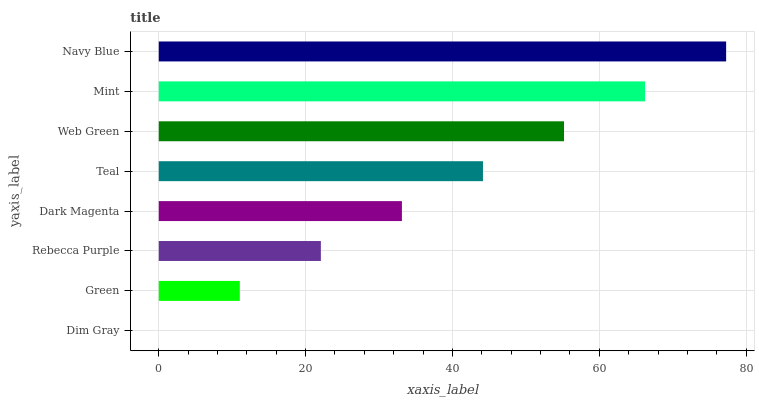Is Dim Gray the minimum?
Answer yes or no. Yes. Is Navy Blue the maximum?
Answer yes or no. Yes. Is Green the minimum?
Answer yes or no. No. Is Green the maximum?
Answer yes or no. No. Is Green greater than Dim Gray?
Answer yes or no. Yes. Is Dim Gray less than Green?
Answer yes or no. Yes. Is Dim Gray greater than Green?
Answer yes or no. No. Is Green less than Dim Gray?
Answer yes or no. No. Is Teal the high median?
Answer yes or no. Yes. Is Dark Magenta the low median?
Answer yes or no. Yes. Is Dim Gray the high median?
Answer yes or no. No. Is Teal the low median?
Answer yes or no. No. 